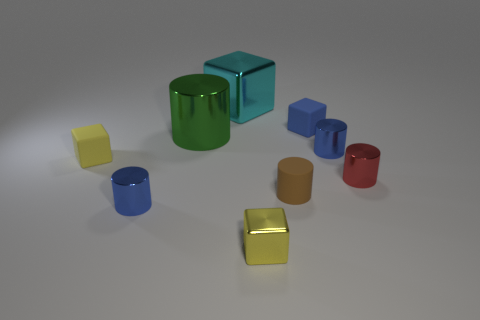How many yellow matte blocks are right of the small cylinder that is in front of the tiny brown thing?
Offer a very short reply. 0. How many other objects are there of the same shape as the small red metal thing?
Offer a very short reply. 4. There is a small object that is the same color as the tiny metal cube; what is its material?
Provide a short and direct response. Rubber. What number of metal things have the same color as the big metallic cylinder?
Make the answer very short. 0. There is a small cylinder that is made of the same material as the small blue block; what color is it?
Keep it short and to the point. Brown. Are there any other red cylinders that have the same size as the matte cylinder?
Your answer should be compact. Yes. Are there more small blue metallic cylinders that are right of the yellow metallic object than tiny rubber cubes that are left of the red metal object?
Your answer should be very brief. No. Is the tiny blue cylinder left of the large shiny cube made of the same material as the yellow cube that is behind the red metallic thing?
Make the answer very short. No. What is the shape of the yellow metal thing that is the same size as the yellow rubber object?
Your answer should be very brief. Cube. Are there any small blue matte things of the same shape as the red shiny thing?
Provide a short and direct response. No. 